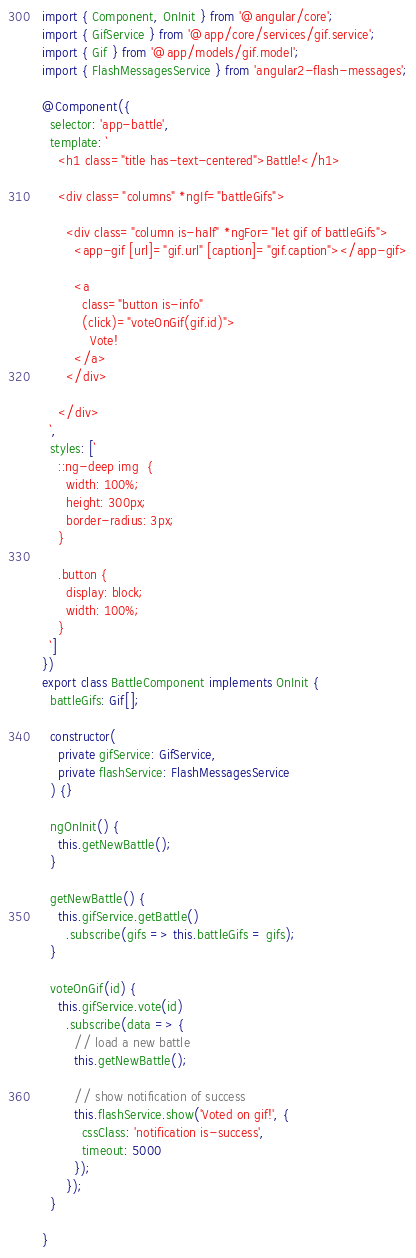<code> <loc_0><loc_0><loc_500><loc_500><_TypeScript_>import { Component, OnInit } from '@angular/core';
import { GifService } from '@app/core/services/gif.service';
import { Gif } from '@app/models/gif.model';
import { FlashMessagesService } from 'angular2-flash-messages';

@Component({
  selector: 'app-battle',
  template: `
    <h1 class="title has-text-centered">Battle!</h1>

    <div class="columns" *ngIf="battleGifs">

      <div class="column is-half" *ngFor="let gif of battleGifs">
        <app-gif [url]="gif.url" [caption]="gif.caption"></app-gif>

        <a 
          class="button is-info" 
          (click)="voteOnGif(gif.id)">
            Vote!
        </a>
      </div>

    </div>
  `,
  styles: [`
    ::ng-deep img  {
      width: 100%;
      height: 300px;
      border-radius: 3px;
    }

    .button {
      display: block;
      width: 100%;
    }
  `]
})
export class BattleComponent implements OnInit {
  battleGifs: Gif[];

  constructor(
    private gifService: GifService,
    private flashService: FlashMessagesService
  ) {}

  ngOnInit() {
    this.getNewBattle();
  }

  getNewBattle() {
    this.gifService.getBattle()
      .subscribe(gifs => this.battleGifs = gifs);
  }

  voteOnGif(id) {
    this.gifService.vote(id)
      .subscribe(data => {
        // load a new battle
        this.getNewBattle();
      
        // show notification of success
        this.flashService.show('Voted on gif!', {
          cssClass: 'notification is-success',
          timeout: 5000
        });
      });
  }

}
</code> 